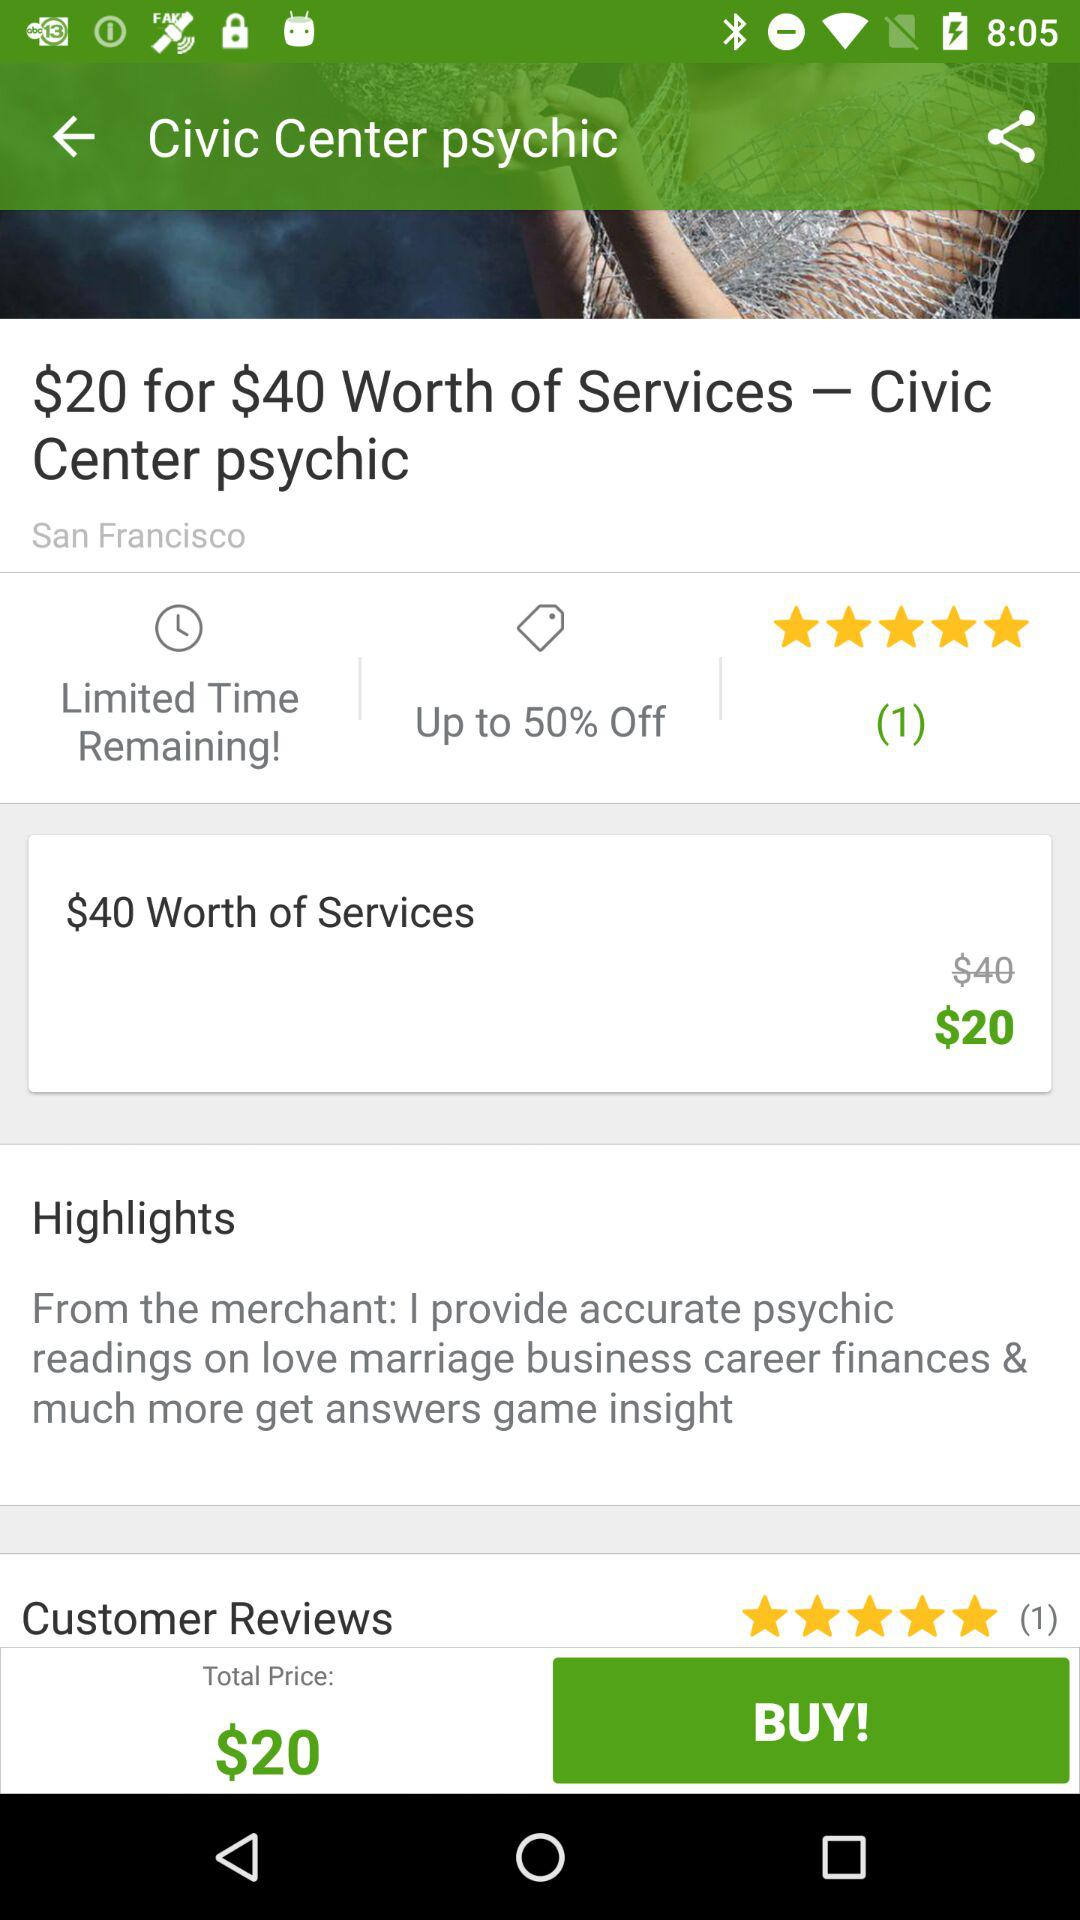How much do I save by buying this deal?
Answer the question using a single word or phrase. $20 